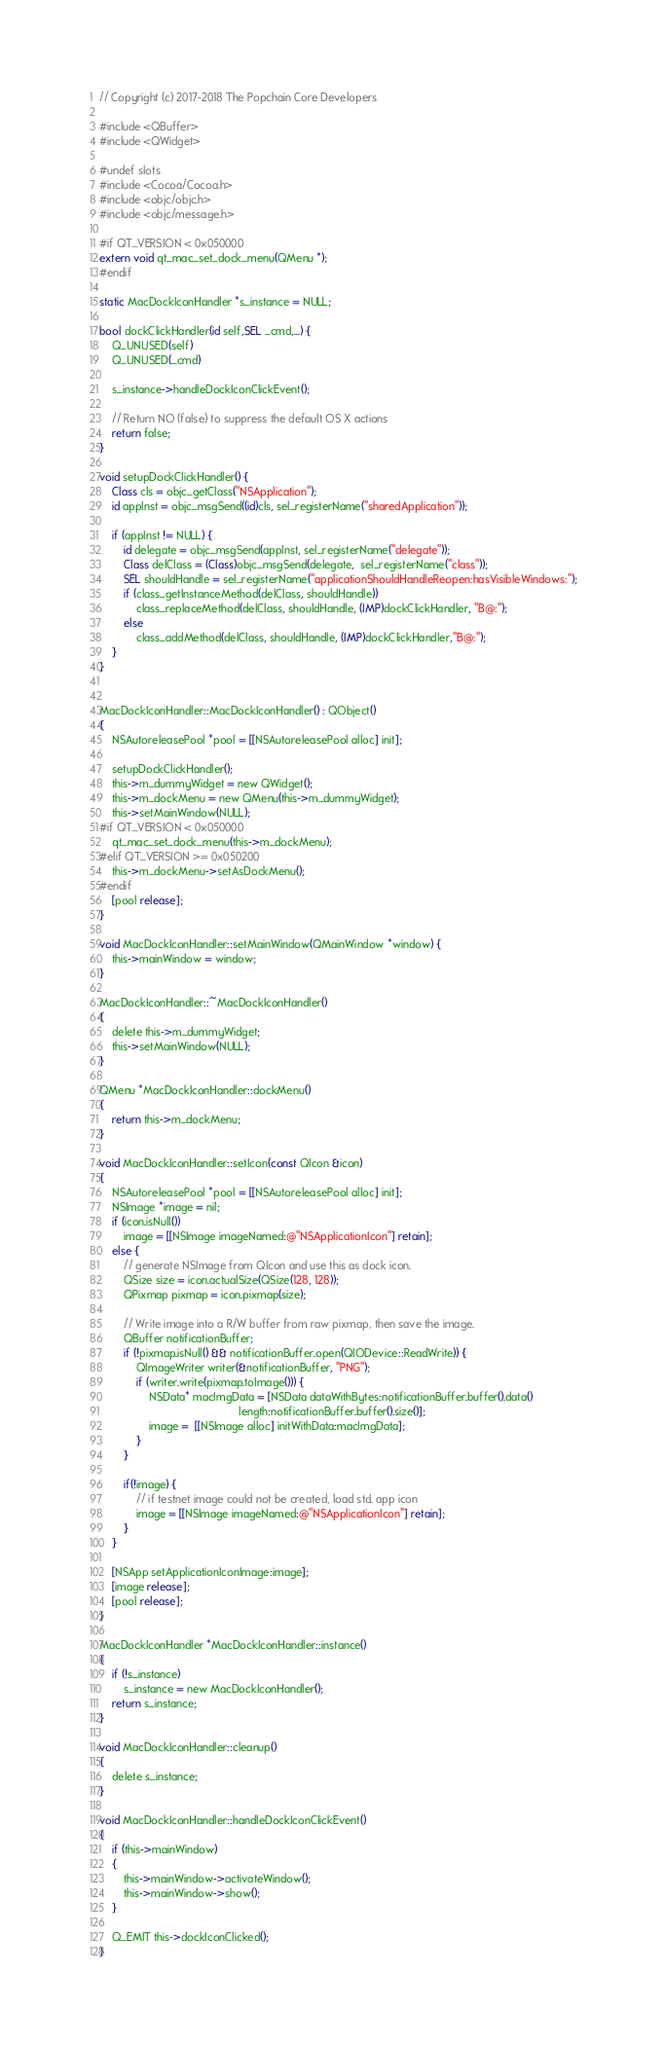Convert code to text. <code><loc_0><loc_0><loc_500><loc_500><_ObjectiveC_>// Copyright (c) 2017-2018 The Popchain Core Developers

#include <QBuffer>
#include <QWidget>

#undef slots
#include <Cocoa/Cocoa.h>
#include <objc/objc.h>
#include <objc/message.h>

#if QT_VERSION < 0x050000
extern void qt_mac_set_dock_menu(QMenu *);
#endif

static MacDockIconHandler *s_instance = NULL;

bool dockClickHandler(id self,SEL _cmd,...) {
    Q_UNUSED(self)
    Q_UNUSED(_cmd)
    
    s_instance->handleDockIconClickEvent();
    
    // Return NO (false) to suppress the default OS X actions
    return false;
}

void setupDockClickHandler() {
    Class cls = objc_getClass("NSApplication");
    id appInst = objc_msgSend((id)cls, sel_registerName("sharedApplication"));
    
    if (appInst != NULL) {
        id delegate = objc_msgSend(appInst, sel_registerName("delegate"));
        Class delClass = (Class)objc_msgSend(delegate,  sel_registerName("class"));
        SEL shouldHandle = sel_registerName("applicationShouldHandleReopen:hasVisibleWindows:");
        if (class_getInstanceMethod(delClass, shouldHandle))
            class_replaceMethod(delClass, shouldHandle, (IMP)dockClickHandler, "B@:");
        else
            class_addMethod(delClass, shouldHandle, (IMP)dockClickHandler,"B@:");
    }
}


MacDockIconHandler::MacDockIconHandler() : QObject()
{
    NSAutoreleasePool *pool = [[NSAutoreleasePool alloc] init];

    setupDockClickHandler();
    this->m_dummyWidget = new QWidget();
    this->m_dockMenu = new QMenu(this->m_dummyWidget);
    this->setMainWindow(NULL);
#if QT_VERSION < 0x050000
    qt_mac_set_dock_menu(this->m_dockMenu);
#elif QT_VERSION >= 0x050200
    this->m_dockMenu->setAsDockMenu();
#endif
    [pool release];
}

void MacDockIconHandler::setMainWindow(QMainWindow *window) {
    this->mainWindow = window;
}

MacDockIconHandler::~MacDockIconHandler()
{
    delete this->m_dummyWidget;
    this->setMainWindow(NULL);
}

QMenu *MacDockIconHandler::dockMenu()
{
    return this->m_dockMenu;
}

void MacDockIconHandler::setIcon(const QIcon &icon)
{
    NSAutoreleasePool *pool = [[NSAutoreleasePool alloc] init];
    NSImage *image = nil;
    if (icon.isNull())
        image = [[NSImage imageNamed:@"NSApplicationIcon"] retain];
    else {
        // generate NSImage from QIcon and use this as dock icon.
        QSize size = icon.actualSize(QSize(128, 128));
        QPixmap pixmap = icon.pixmap(size);

        // Write image into a R/W buffer from raw pixmap, then save the image.
        QBuffer notificationBuffer;
        if (!pixmap.isNull() && notificationBuffer.open(QIODevice::ReadWrite)) {
            QImageWriter writer(&notificationBuffer, "PNG");
            if (writer.write(pixmap.toImage())) {
                NSData* macImgData = [NSData dataWithBytes:notificationBuffer.buffer().data()
                                             length:notificationBuffer.buffer().size()];
                image =  [[NSImage alloc] initWithData:macImgData];
            }
        }

        if(!image) {
            // if testnet image could not be created, load std. app icon
            image = [[NSImage imageNamed:@"NSApplicationIcon"] retain];
        }
    }

    [NSApp setApplicationIconImage:image];
    [image release];
    [pool release];
}

MacDockIconHandler *MacDockIconHandler::instance()
{
    if (!s_instance)
        s_instance = new MacDockIconHandler();
    return s_instance;
}

void MacDockIconHandler::cleanup()
{
    delete s_instance;
}

void MacDockIconHandler::handleDockIconClickEvent()
{
    if (this->mainWindow)
    {
        this->mainWindow->activateWindow();
        this->mainWindow->show();
    }

    Q_EMIT this->dockIconClicked();
}
</code> 